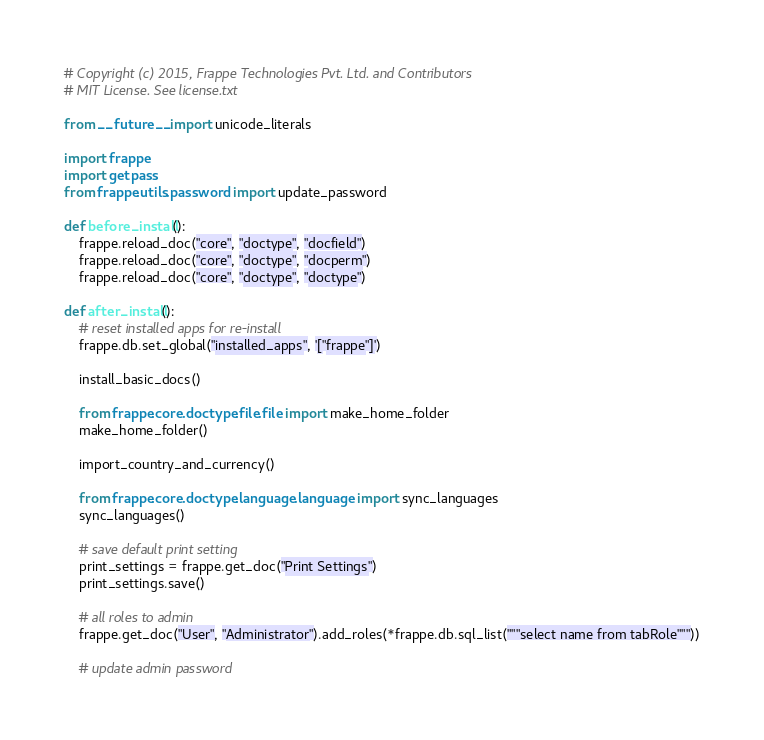Convert code to text. <code><loc_0><loc_0><loc_500><loc_500><_Python_># Copyright (c) 2015, Frappe Technologies Pvt. Ltd. and Contributors
# MIT License. See license.txt

from __future__ import unicode_literals

import frappe
import getpass
from frappe.utils.password import update_password

def before_install():
	frappe.reload_doc("core", "doctype", "docfield")
	frappe.reload_doc("core", "doctype", "docperm")
	frappe.reload_doc("core", "doctype", "doctype")

def after_install():
	# reset installed apps for re-install
	frappe.db.set_global("installed_apps", '["frappe"]')

	install_basic_docs()

	from frappe.core.doctype.file.file import make_home_folder
	make_home_folder()

	import_country_and_currency()

	from frappe.core.doctype.language.language import sync_languages
	sync_languages()

	# save default print setting
	print_settings = frappe.get_doc("Print Settings")
	print_settings.save()

	# all roles to admin
	frappe.get_doc("User", "Administrator").add_roles(*frappe.db.sql_list("""select name from tabRole"""))

	# update admin password</code> 